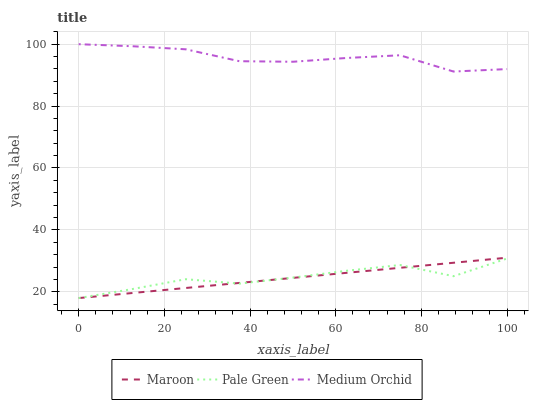Does Maroon have the minimum area under the curve?
Answer yes or no. Yes. Does Medium Orchid have the maximum area under the curve?
Answer yes or no. Yes. Does Pale Green have the minimum area under the curve?
Answer yes or no. No. Does Pale Green have the maximum area under the curve?
Answer yes or no. No. Is Maroon the smoothest?
Answer yes or no. Yes. Is Pale Green the roughest?
Answer yes or no. Yes. Is Pale Green the smoothest?
Answer yes or no. No. Is Maroon the roughest?
Answer yes or no. No. Does Pale Green have the lowest value?
Answer yes or no. Yes. Does Medium Orchid have the highest value?
Answer yes or no. Yes. Does Maroon have the highest value?
Answer yes or no. No. Is Maroon less than Medium Orchid?
Answer yes or no. Yes. Is Medium Orchid greater than Pale Green?
Answer yes or no. Yes. Does Maroon intersect Pale Green?
Answer yes or no. Yes. Is Maroon less than Pale Green?
Answer yes or no. No. Is Maroon greater than Pale Green?
Answer yes or no. No. Does Maroon intersect Medium Orchid?
Answer yes or no. No. 